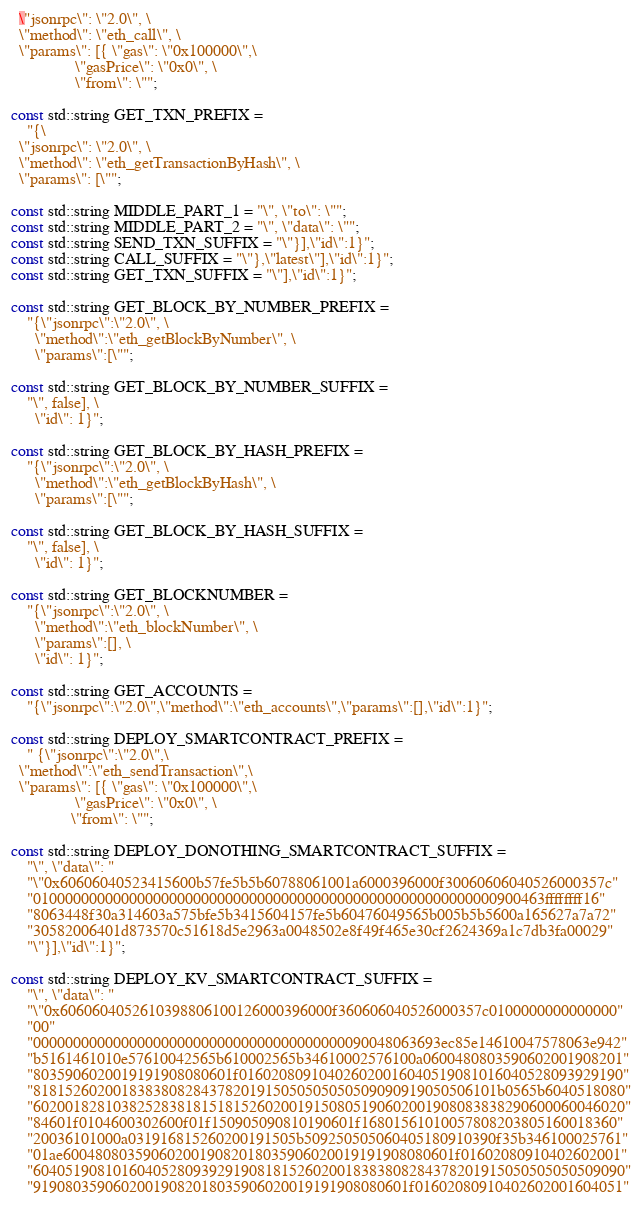<code> <loc_0><loc_0><loc_500><loc_500><_C++_>  \"jsonrpc\": \"2.0\", \
  \"method\": \"eth_call\", \
  \"params\": [{ \"gas\": \"0x100000\",\
                \"gasPrice\": \"0x0\", \
                \"from\": \"";

const std::string GET_TXN_PREFIX =
    "{\
  \"jsonrpc\": \"2.0\", \
  \"method\": \"eth_getTransactionByHash\", \
  \"params\": [\"";

const std::string MIDDLE_PART_1 = "\", \"to\": \"";
const std::string MIDDLE_PART_2 = "\", \"data\": \"";
const std::string SEND_TXN_SUFFIX = "\"}],\"id\":1}";
const std::string CALL_SUFFIX = "\"},\"latest\"],\"id\":1}";
const std::string GET_TXN_SUFFIX = "\"],\"id\":1}";

const std::string GET_BLOCK_BY_NUMBER_PREFIX =
    "{\"jsonrpc\":\"2.0\", \
      \"method\":\"eth_getBlockByNumber\", \
      \"params\":[\"";

const std::string GET_BLOCK_BY_NUMBER_SUFFIX =
    "\", false], \
      \"id\": 1}";

const std::string GET_BLOCK_BY_HASH_PREFIX =
    "{\"jsonrpc\":\"2.0\", \
      \"method\":\"eth_getBlockByHash\", \
      \"params\":[\"";

const std::string GET_BLOCK_BY_HASH_SUFFIX =
    "\", false], \
      \"id\": 1}";

const std::string GET_BLOCKNUMBER =
    "{\"jsonrpc\":\"2.0\", \
      \"method\":\"eth_blockNumber\", \
      \"params\":[], \
      \"id\": 1}";

const std::string GET_ACCOUNTS =
    "{\"jsonrpc\":\"2.0\",\"method\":\"eth_accounts\",\"params\":[],\"id\":1}";

const std::string DEPLOY_SMARTCONTRACT_PREFIX =
    " {\"jsonrpc\":\"2.0\",\
  \"method\":\"eth_sendTransaction\",\
  \"params\": [{ \"gas\": \"0x100000\",\
                \"gasPrice\": \"0x0\", \
               \"from\": \"";

const std::string DEPLOY_DONOTHING_SMARTCONTRACT_SUFFIX =
    "\", \"data\": "
    "\"0x60606040523415600b57fe5b5b60788061001a6000396000f30060606040526000357c"
    "0100000000000000000000000000000000000000000000000000000000900463ffffffff16"
    "8063448f30a314603a575bfe5b3415604157fe5b60476049565b005b5b5600a165627a7a72"
    "30582006401d873570c51618d5e2963a0048502e8f49f465e30cf2624369a1c7db3fa00029"
    "\"}],\"id\":1}";

const std::string DEPLOY_KV_SMARTCONTRACT_SUFFIX =
    "\", \"data\": "
    "\"0x6060604052610398806100126000396000f360606040526000357c0100000000000000"
    "00"
    "000000000000000000000000000000000000000090048063693ec85e14610047578063e942"
    "b5161461010e57610042565b610002565b34610002576100a0600480803590602001908201"
    "8035906020019191908080601f016020809104026020016040519081016040528093929190"
    "8181526020018383808284378201915050505050509090919050506101b0565b6040518080"
    "60200182810382528381815181526020019150805190602001908083838290600060046020"
    "84601f0104600302600f01f150905090810190601f16801561010057808203805160018360"
    "20036101000a031916815260200191505b509250505060405180910390f35b346100025761"
    "01ae6004808035906020019082018035906020019191908080601f01602080910402602001"
    "60405190810160405280939291908181526020018383808284378201915050505050509090"
    "91908035906020019082018035906020019191908080601f01602080910402602001604051"</code> 